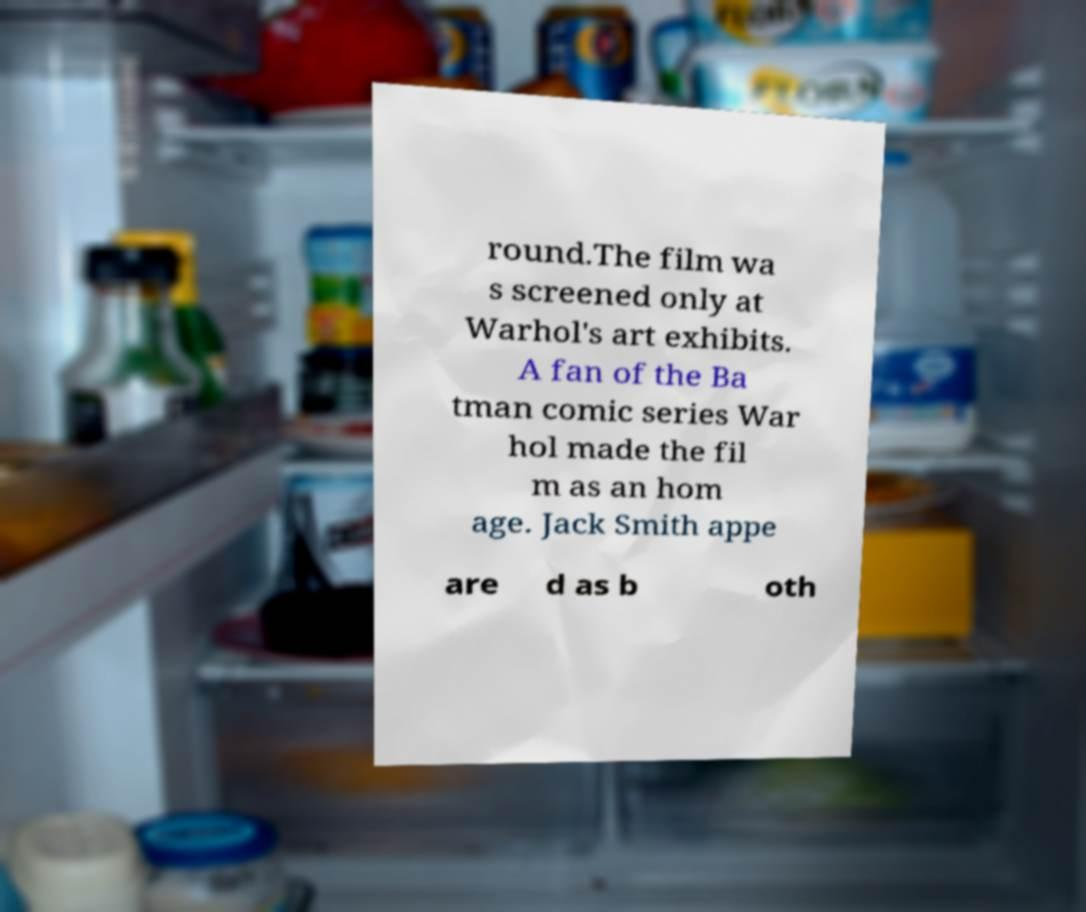Can you read and provide the text displayed in the image?This photo seems to have some interesting text. Can you extract and type it out for me? round.The film wa s screened only at Warhol's art exhibits. A fan of the Ba tman comic series War hol made the fil m as an hom age. Jack Smith appe are d as b oth 